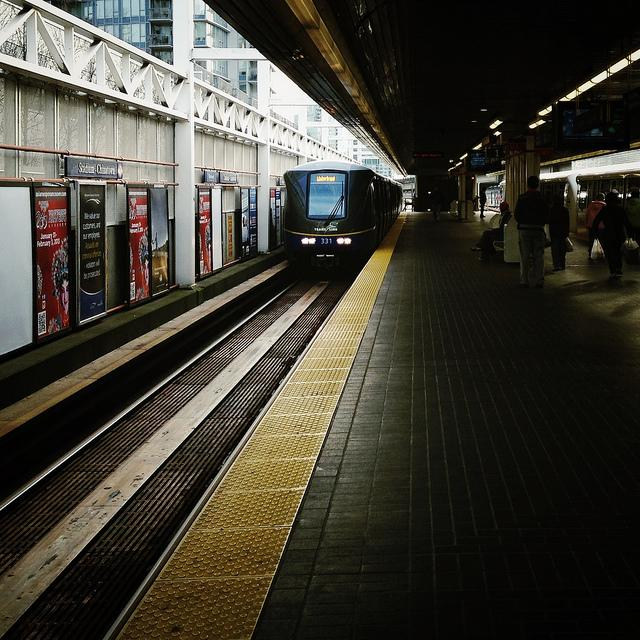What are the colorful posters on the wall used for? Please explain your reasoning. advertising. Posters are used to get attention. 